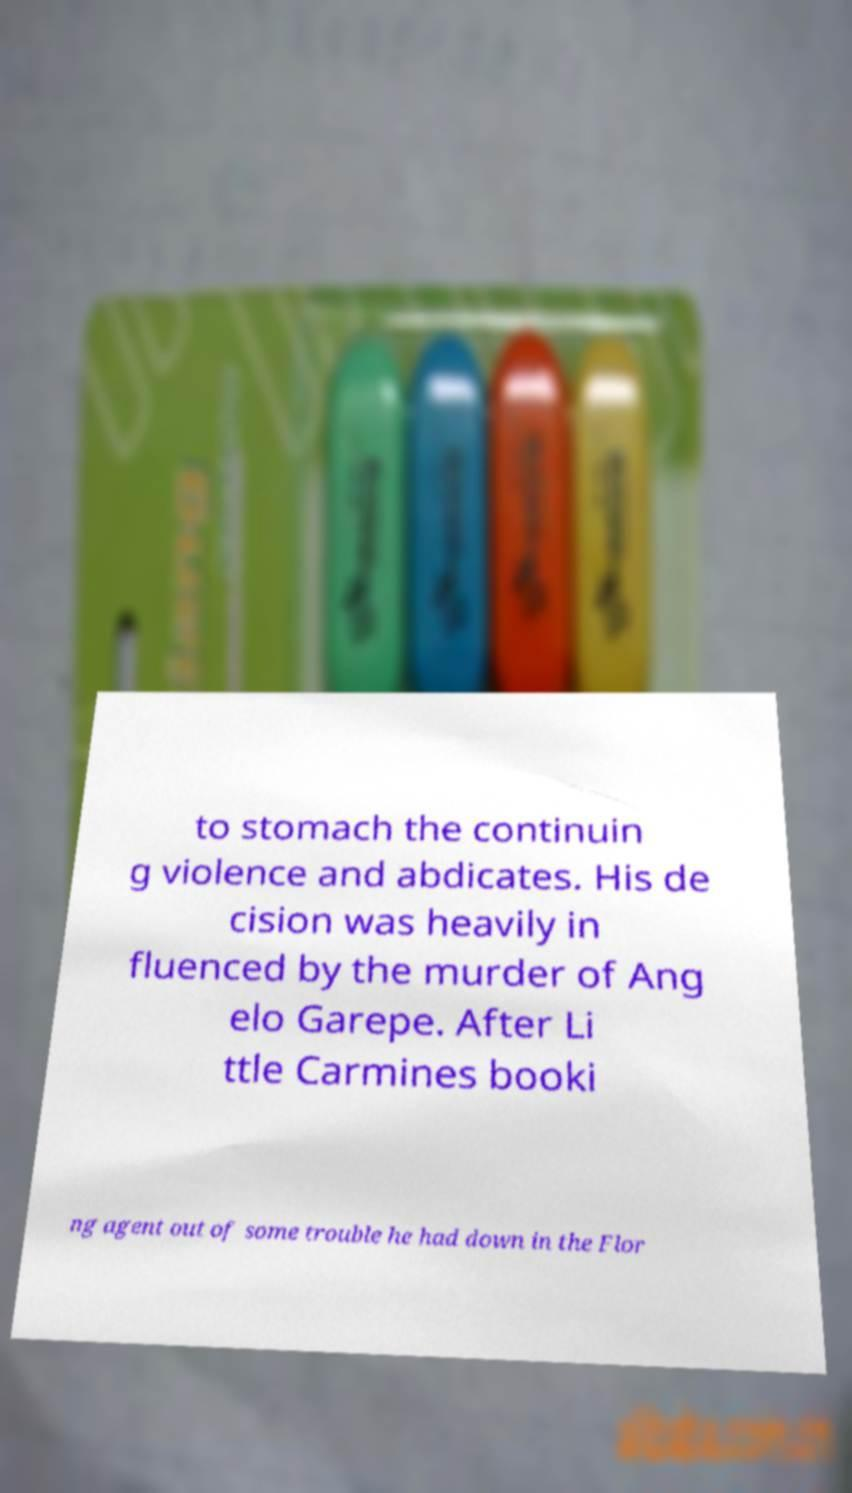Could you extract and type out the text from this image? to stomach the continuin g violence and abdicates. His de cision was heavily in fluenced by the murder of Ang elo Garepe. After Li ttle Carmines booki ng agent out of some trouble he had down in the Flor 